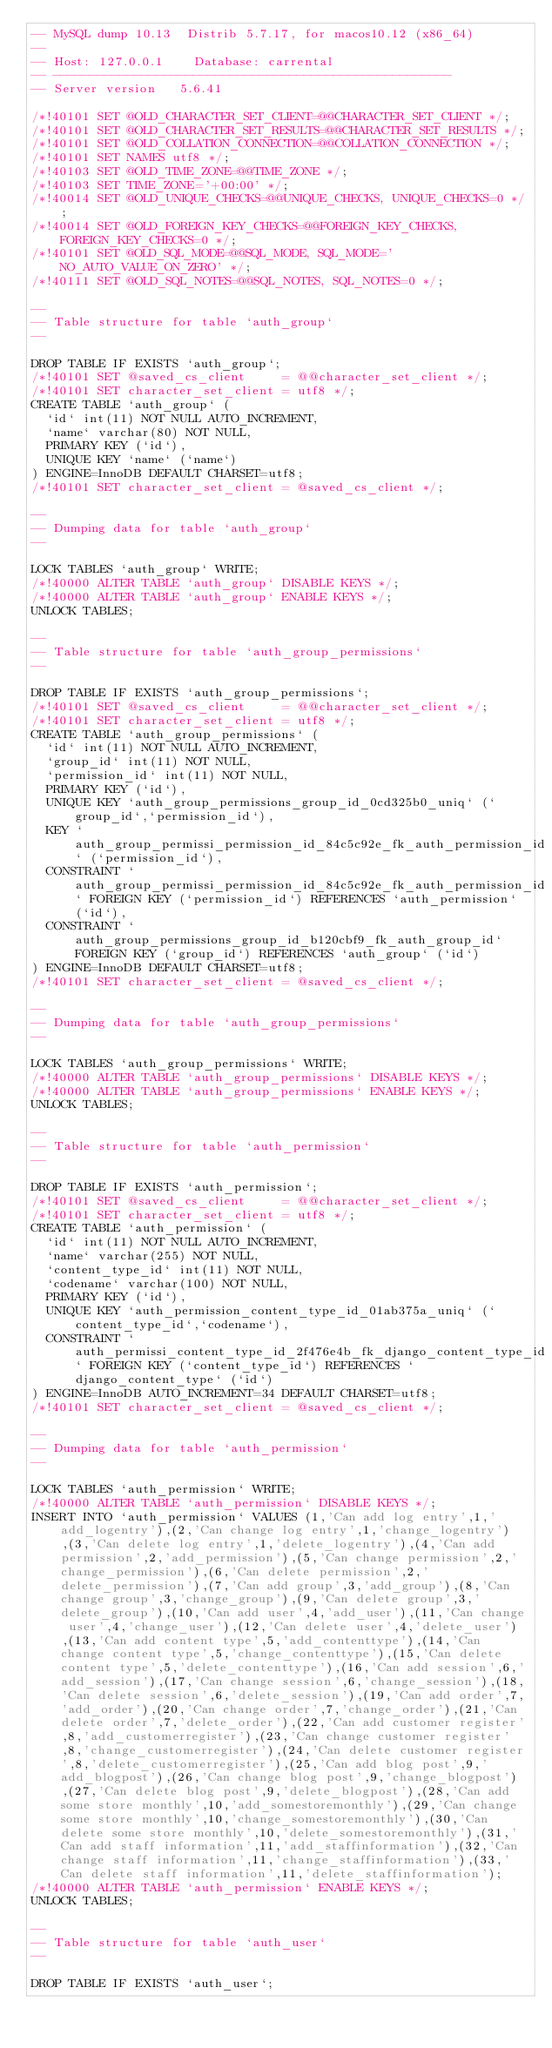Convert code to text. <code><loc_0><loc_0><loc_500><loc_500><_SQL_>-- MySQL dump 10.13  Distrib 5.7.17, for macos10.12 (x86_64)
--
-- Host: 127.0.0.1    Database: carrental
-- ------------------------------------------------------
-- Server version	5.6.41

/*!40101 SET @OLD_CHARACTER_SET_CLIENT=@@CHARACTER_SET_CLIENT */;
/*!40101 SET @OLD_CHARACTER_SET_RESULTS=@@CHARACTER_SET_RESULTS */;
/*!40101 SET @OLD_COLLATION_CONNECTION=@@COLLATION_CONNECTION */;
/*!40101 SET NAMES utf8 */;
/*!40103 SET @OLD_TIME_ZONE=@@TIME_ZONE */;
/*!40103 SET TIME_ZONE='+00:00' */;
/*!40014 SET @OLD_UNIQUE_CHECKS=@@UNIQUE_CHECKS, UNIQUE_CHECKS=0 */;
/*!40014 SET @OLD_FOREIGN_KEY_CHECKS=@@FOREIGN_KEY_CHECKS, FOREIGN_KEY_CHECKS=0 */;
/*!40101 SET @OLD_SQL_MODE=@@SQL_MODE, SQL_MODE='NO_AUTO_VALUE_ON_ZERO' */;
/*!40111 SET @OLD_SQL_NOTES=@@SQL_NOTES, SQL_NOTES=0 */;

--
-- Table structure for table `auth_group`
--

DROP TABLE IF EXISTS `auth_group`;
/*!40101 SET @saved_cs_client     = @@character_set_client */;
/*!40101 SET character_set_client = utf8 */;
CREATE TABLE `auth_group` (
  `id` int(11) NOT NULL AUTO_INCREMENT,
  `name` varchar(80) NOT NULL,
  PRIMARY KEY (`id`),
  UNIQUE KEY `name` (`name`)
) ENGINE=InnoDB DEFAULT CHARSET=utf8;
/*!40101 SET character_set_client = @saved_cs_client */;

--
-- Dumping data for table `auth_group`
--

LOCK TABLES `auth_group` WRITE;
/*!40000 ALTER TABLE `auth_group` DISABLE KEYS */;
/*!40000 ALTER TABLE `auth_group` ENABLE KEYS */;
UNLOCK TABLES;

--
-- Table structure for table `auth_group_permissions`
--

DROP TABLE IF EXISTS `auth_group_permissions`;
/*!40101 SET @saved_cs_client     = @@character_set_client */;
/*!40101 SET character_set_client = utf8 */;
CREATE TABLE `auth_group_permissions` (
  `id` int(11) NOT NULL AUTO_INCREMENT,
  `group_id` int(11) NOT NULL,
  `permission_id` int(11) NOT NULL,
  PRIMARY KEY (`id`),
  UNIQUE KEY `auth_group_permissions_group_id_0cd325b0_uniq` (`group_id`,`permission_id`),
  KEY `auth_group_permissi_permission_id_84c5c92e_fk_auth_permission_id` (`permission_id`),
  CONSTRAINT `auth_group_permissi_permission_id_84c5c92e_fk_auth_permission_id` FOREIGN KEY (`permission_id`) REFERENCES `auth_permission` (`id`),
  CONSTRAINT `auth_group_permissions_group_id_b120cbf9_fk_auth_group_id` FOREIGN KEY (`group_id`) REFERENCES `auth_group` (`id`)
) ENGINE=InnoDB DEFAULT CHARSET=utf8;
/*!40101 SET character_set_client = @saved_cs_client */;

--
-- Dumping data for table `auth_group_permissions`
--

LOCK TABLES `auth_group_permissions` WRITE;
/*!40000 ALTER TABLE `auth_group_permissions` DISABLE KEYS */;
/*!40000 ALTER TABLE `auth_group_permissions` ENABLE KEYS */;
UNLOCK TABLES;

--
-- Table structure for table `auth_permission`
--

DROP TABLE IF EXISTS `auth_permission`;
/*!40101 SET @saved_cs_client     = @@character_set_client */;
/*!40101 SET character_set_client = utf8 */;
CREATE TABLE `auth_permission` (
  `id` int(11) NOT NULL AUTO_INCREMENT,
  `name` varchar(255) NOT NULL,
  `content_type_id` int(11) NOT NULL,
  `codename` varchar(100) NOT NULL,
  PRIMARY KEY (`id`),
  UNIQUE KEY `auth_permission_content_type_id_01ab375a_uniq` (`content_type_id`,`codename`),
  CONSTRAINT `auth_permissi_content_type_id_2f476e4b_fk_django_content_type_id` FOREIGN KEY (`content_type_id`) REFERENCES `django_content_type` (`id`)
) ENGINE=InnoDB AUTO_INCREMENT=34 DEFAULT CHARSET=utf8;
/*!40101 SET character_set_client = @saved_cs_client */;

--
-- Dumping data for table `auth_permission`
--

LOCK TABLES `auth_permission` WRITE;
/*!40000 ALTER TABLE `auth_permission` DISABLE KEYS */;
INSERT INTO `auth_permission` VALUES (1,'Can add log entry',1,'add_logentry'),(2,'Can change log entry',1,'change_logentry'),(3,'Can delete log entry',1,'delete_logentry'),(4,'Can add permission',2,'add_permission'),(5,'Can change permission',2,'change_permission'),(6,'Can delete permission',2,'delete_permission'),(7,'Can add group',3,'add_group'),(8,'Can change group',3,'change_group'),(9,'Can delete group',3,'delete_group'),(10,'Can add user',4,'add_user'),(11,'Can change user',4,'change_user'),(12,'Can delete user',4,'delete_user'),(13,'Can add content type',5,'add_contenttype'),(14,'Can change content type',5,'change_contenttype'),(15,'Can delete content type',5,'delete_contenttype'),(16,'Can add session',6,'add_session'),(17,'Can change session',6,'change_session'),(18,'Can delete session',6,'delete_session'),(19,'Can add order',7,'add_order'),(20,'Can change order',7,'change_order'),(21,'Can delete order',7,'delete_order'),(22,'Can add customer register',8,'add_customerregister'),(23,'Can change customer register',8,'change_customerregister'),(24,'Can delete customer register',8,'delete_customerregister'),(25,'Can add blog post',9,'add_blogpost'),(26,'Can change blog post',9,'change_blogpost'),(27,'Can delete blog post',9,'delete_blogpost'),(28,'Can add some store monthly',10,'add_somestoremonthly'),(29,'Can change some store monthly',10,'change_somestoremonthly'),(30,'Can delete some store monthly',10,'delete_somestoremonthly'),(31,'Can add staff information',11,'add_staffinformation'),(32,'Can change staff information',11,'change_staffinformation'),(33,'Can delete staff information',11,'delete_staffinformation');
/*!40000 ALTER TABLE `auth_permission` ENABLE KEYS */;
UNLOCK TABLES;

--
-- Table structure for table `auth_user`
--

DROP TABLE IF EXISTS `auth_user`;</code> 